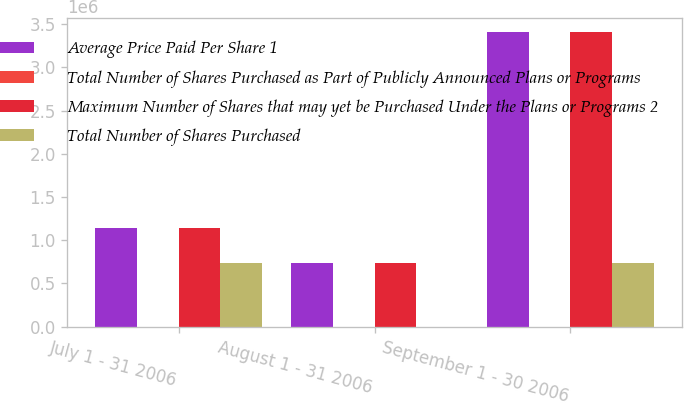Convert chart. <chart><loc_0><loc_0><loc_500><loc_500><stacked_bar_chart><ecel><fcel>July 1 - 31 2006<fcel>August 1 - 31 2006<fcel>September 1 - 30 2006<nl><fcel>Average Price Paid Per Share 1<fcel>1.1454e+06<fcel>735200<fcel>3.4072e+06<nl><fcel>Total Number of Shares Purchased as Part of Publicly Announced Plans or Programs<fcel>64.75<fcel>62.54<fcel>56.11<nl><fcel>Maximum Number of Shares that may yet be Purchased Under the Plans or Programs 2<fcel>1.1454e+06<fcel>735200<fcel>3.4072e+06<nl><fcel>Total Number of Shares Purchased<fcel>735200<fcel>0<fcel>735200<nl></chart> 